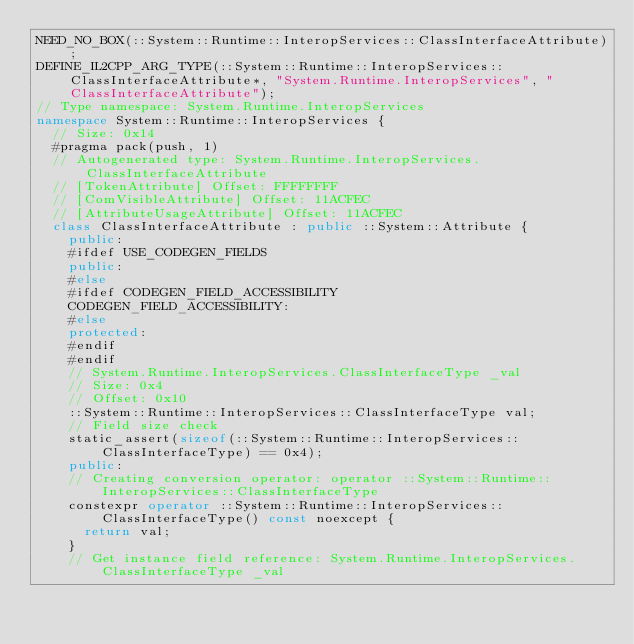<code> <loc_0><loc_0><loc_500><loc_500><_C++_>NEED_NO_BOX(::System::Runtime::InteropServices::ClassInterfaceAttribute);
DEFINE_IL2CPP_ARG_TYPE(::System::Runtime::InteropServices::ClassInterfaceAttribute*, "System.Runtime.InteropServices", "ClassInterfaceAttribute");
// Type namespace: System.Runtime.InteropServices
namespace System::Runtime::InteropServices {
  // Size: 0x14
  #pragma pack(push, 1)
  // Autogenerated type: System.Runtime.InteropServices.ClassInterfaceAttribute
  // [TokenAttribute] Offset: FFFFFFFF
  // [ComVisibleAttribute] Offset: 11ACFEC
  // [AttributeUsageAttribute] Offset: 11ACFEC
  class ClassInterfaceAttribute : public ::System::Attribute {
    public:
    #ifdef USE_CODEGEN_FIELDS
    public:
    #else
    #ifdef CODEGEN_FIELD_ACCESSIBILITY
    CODEGEN_FIELD_ACCESSIBILITY:
    #else
    protected:
    #endif
    #endif
    // System.Runtime.InteropServices.ClassInterfaceType _val
    // Size: 0x4
    // Offset: 0x10
    ::System::Runtime::InteropServices::ClassInterfaceType val;
    // Field size check
    static_assert(sizeof(::System::Runtime::InteropServices::ClassInterfaceType) == 0x4);
    public:
    // Creating conversion operator: operator ::System::Runtime::InteropServices::ClassInterfaceType
    constexpr operator ::System::Runtime::InteropServices::ClassInterfaceType() const noexcept {
      return val;
    }
    // Get instance field reference: System.Runtime.InteropServices.ClassInterfaceType _val</code> 